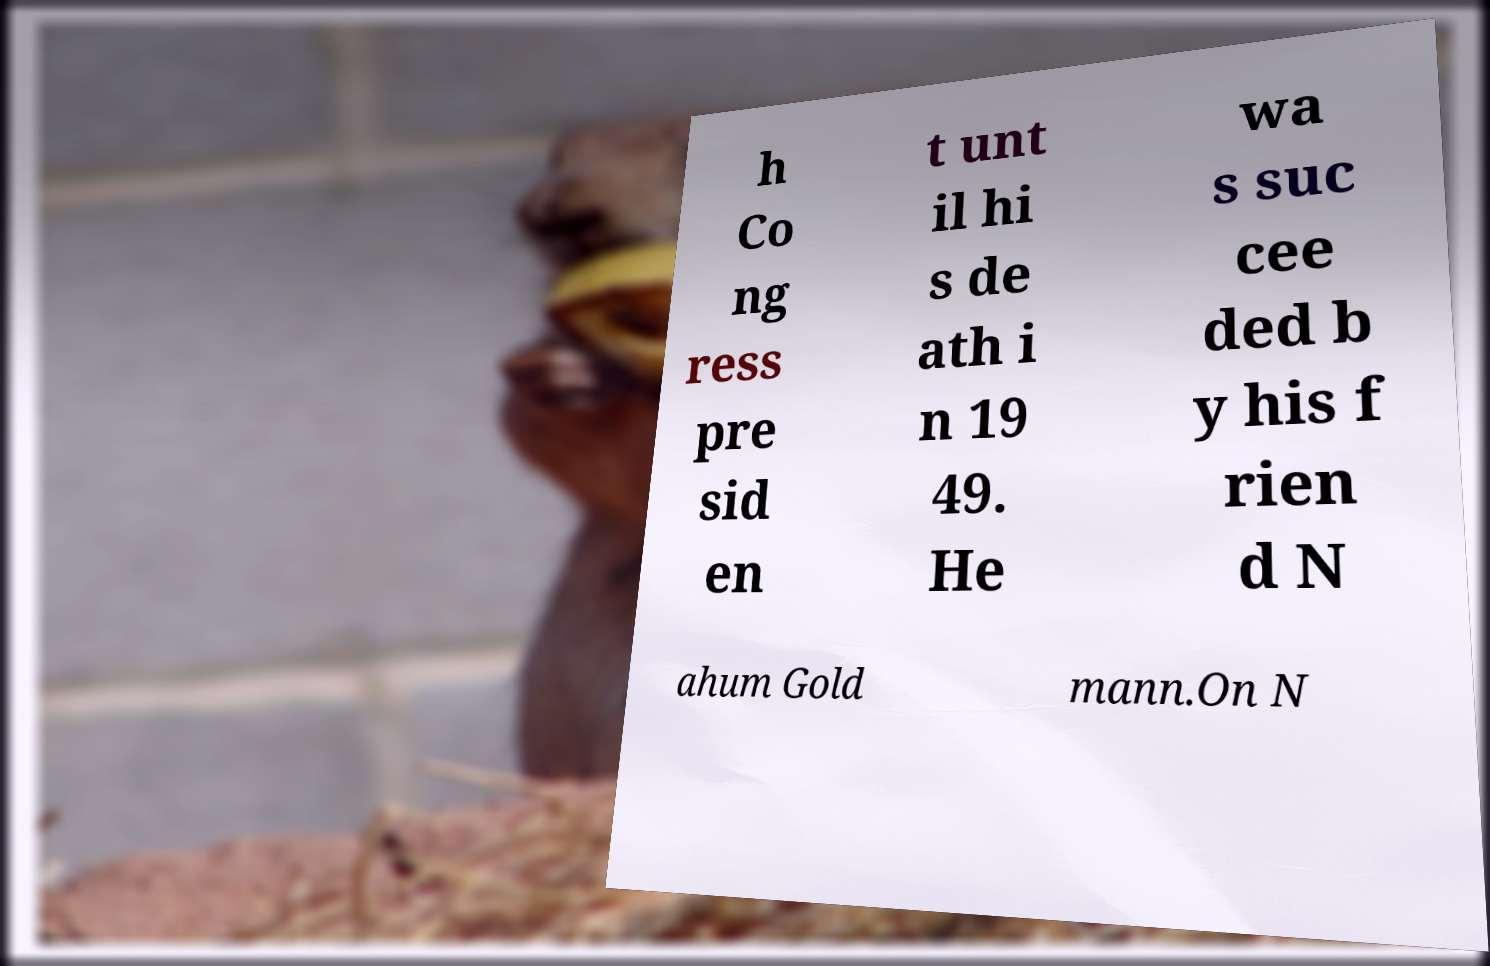What messages or text are displayed in this image? I need them in a readable, typed format. h Co ng ress pre sid en t unt il hi s de ath i n 19 49. He wa s suc cee ded b y his f rien d N ahum Gold mann.On N 